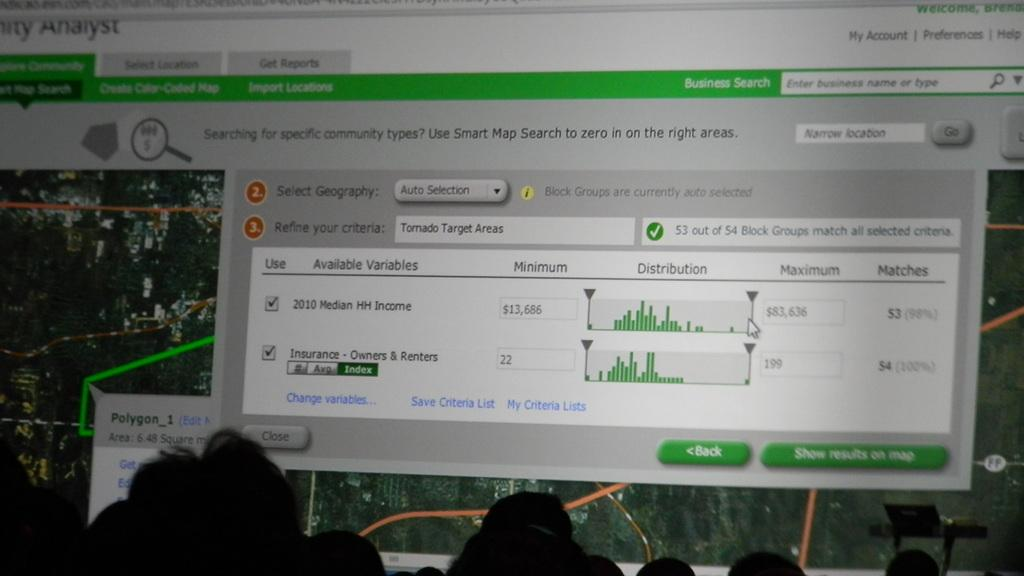What is the main subject of the image? The main subject of the image is a screen of a system. What can be seen on the screen? Data is visible on the screen. Can you describe the presence of people in the image? There are shadows of people's heads in front of the screen. What type of copper material is used to create the screen in the image? There is no mention of copper or any specific material used for the screen in the image. 